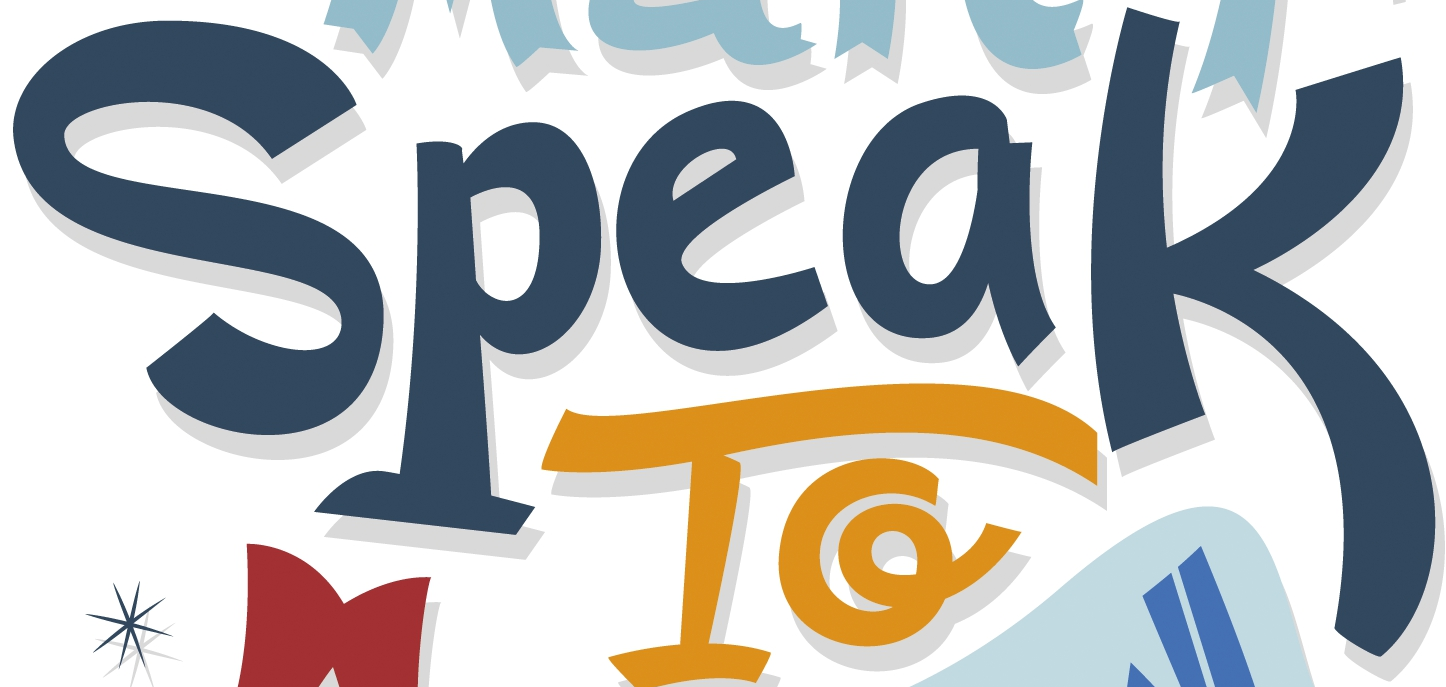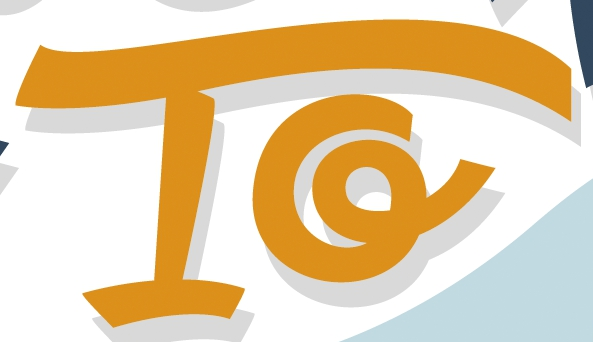What words are shown in these images in order, separated by a semicolon? Speak; To 